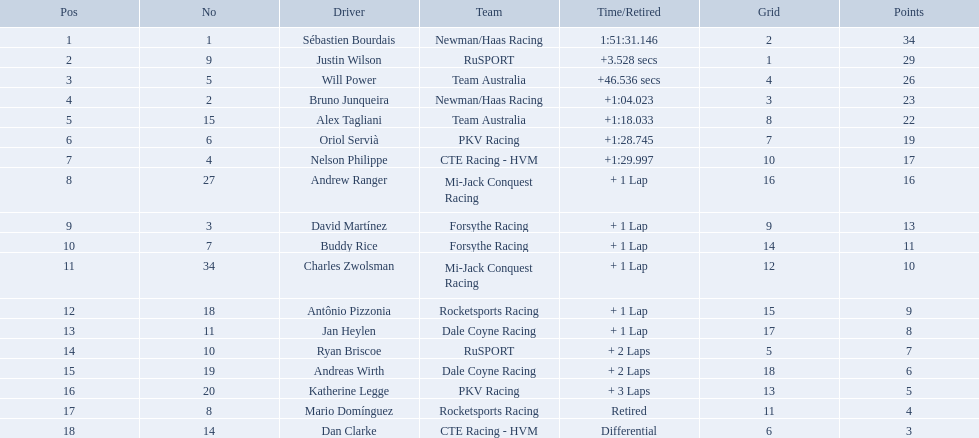How many points did first place receive? 34. How many did last place receive? 3. Who was the recipient of these last place points? Dan Clarke. Which teams participated in the 2006 gran premio telmex? Newman/Haas Racing, RuSPORT, Team Australia, Newman/Haas Racing, Team Australia, PKV Racing, CTE Racing - HVM, Mi-Jack Conquest Racing, Forsythe Racing, Forsythe Racing, Mi-Jack Conquest Racing, Rocketsports Racing, Dale Coyne Racing, RuSPORT, Dale Coyne Racing, PKV Racing, Rocketsports Racing, CTE Racing - HVM. Who were the drivers of these teams? Sébastien Bourdais, Justin Wilson, Will Power, Bruno Junqueira, Alex Tagliani, Oriol Servià, Nelson Philippe, Andrew Ranger, David Martínez, Buddy Rice, Charles Zwolsman, Antônio Pizzonia, Jan Heylen, Ryan Briscoe, Andreas Wirth, Katherine Legge, Mario Domínguez, Dan Clarke. Which driver finished last? Dan Clarke. What are the names of the drivers who were in position 14 through position 18? Ryan Briscoe, Andreas Wirth, Katherine Legge, Mario Domínguez, Dan Clarke. Of these , which ones didn't finish due to retired or differential? Mario Domínguez, Dan Clarke. Which one of the previous drivers retired? Mario Domínguez. Which of the drivers in question 2 had a differential? Dan Clarke. Parse the full table in json format. {'header': ['Pos', 'No', 'Driver', 'Team', 'Time/Retired', 'Grid', 'Points'], 'rows': [['1', '1', 'Sébastien Bourdais', 'Newman/Haas Racing', '1:51:31.146', '2', '34'], ['2', '9', 'Justin Wilson', 'RuSPORT', '+3.528 secs', '1', '29'], ['3', '5', 'Will Power', 'Team Australia', '+46.536 secs', '4', '26'], ['4', '2', 'Bruno Junqueira', 'Newman/Haas Racing', '+1:04.023', '3', '23'], ['5', '15', 'Alex Tagliani', 'Team Australia', '+1:18.033', '8', '22'], ['6', '6', 'Oriol Servià', 'PKV Racing', '+1:28.745', '7', '19'], ['7', '4', 'Nelson Philippe', 'CTE Racing - HVM', '+1:29.997', '10', '17'], ['8', '27', 'Andrew Ranger', 'Mi-Jack Conquest Racing', '+ 1 Lap', '16', '16'], ['9', '3', 'David Martínez', 'Forsythe Racing', '+ 1 Lap', '9', '13'], ['10', '7', 'Buddy Rice', 'Forsythe Racing', '+ 1 Lap', '14', '11'], ['11', '34', 'Charles Zwolsman', 'Mi-Jack Conquest Racing', '+ 1 Lap', '12', '10'], ['12', '18', 'Antônio Pizzonia', 'Rocketsports Racing', '+ 1 Lap', '15', '9'], ['13', '11', 'Jan Heylen', 'Dale Coyne Racing', '+ 1 Lap', '17', '8'], ['14', '10', 'Ryan Briscoe', 'RuSPORT', '+ 2 Laps', '5', '7'], ['15', '19', 'Andreas Wirth', 'Dale Coyne Racing', '+ 2 Laps', '18', '6'], ['16', '20', 'Katherine Legge', 'PKV Racing', '+ 3 Laps', '13', '5'], ['17', '8', 'Mario Domínguez', 'Rocketsports Racing', 'Retired', '11', '4'], ['18', '14', 'Dan Clarke', 'CTE Racing - HVM', 'Differential', '6', '3']]} Parse the full table in json format. {'header': ['Pos', 'No', 'Driver', 'Team', 'Time/Retired', 'Grid', 'Points'], 'rows': [['1', '1', 'Sébastien Bourdais', 'Newman/Haas Racing', '1:51:31.146', '2', '34'], ['2', '9', 'Justin Wilson', 'RuSPORT', '+3.528 secs', '1', '29'], ['3', '5', 'Will Power', 'Team Australia', '+46.536 secs', '4', '26'], ['4', '2', 'Bruno Junqueira', 'Newman/Haas Racing', '+1:04.023', '3', '23'], ['5', '15', 'Alex Tagliani', 'Team Australia', '+1:18.033', '8', '22'], ['6', '6', 'Oriol Servià', 'PKV Racing', '+1:28.745', '7', '19'], ['7', '4', 'Nelson Philippe', 'CTE Racing - HVM', '+1:29.997', '10', '17'], ['8', '27', 'Andrew Ranger', 'Mi-Jack Conquest Racing', '+ 1 Lap', '16', '16'], ['9', '3', 'David Martínez', 'Forsythe Racing', '+ 1 Lap', '9', '13'], ['10', '7', 'Buddy Rice', 'Forsythe Racing', '+ 1 Lap', '14', '11'], ['11', '34', 'Charles Zwolsman', 'Mi-Jack Conquest Racing', '+ 1 Lap', '12', '10'], ['12', '18', 'Antônio Pizzonia', 'Rocketsports Racing', '+ 1 Lap', '15', '9'], ['13', '11', 'Jan Heylen', 'Dale Coyne Racing', '+ 1 Lap', '17', '8'], ['14', '10', 'Ryan Briscoe', 'RuSPORT', '+ 2 Laps', '5', '7'], ['15', '19', 'Andreas Wirth', 'Dale Coyne Racing', '+ 2 Laps', '18', '6'], ['16', '20', 'Katherine Legge', 'PKV Racing', '+ 3 Laps', '13', '5'], ['17', '8', 'Mario Domínguez', 'Rocketsports Racing', 'Retired', '11', '4'], ['18', '14', 'Dan Clarke', 'CTE Racing - HVM', 'Differential', '6', '3']]} What drivers started in the top 10? Sébastien Bourdais, Justin Wilson, Will Power, Bruno Junqueira, Alex Tagliani, Oriol Servià, Nelson Philippe, Ryan Briscoe, Dan Clarke. Which of those drivers completed all 66 laps? Sébastien Bourdais, Justin Wilson, Will Power, Bruno Junqueira, Alex Tagliani, Oriol Servià, Nelson Philippe. Whom of these did not drive for team australia? Sébastien Bourdais, Justin Wilson, Bruno Junqueira, Oriol Servià, Nelson Philippe. Which of these drivers finished more then a minuet after the winner? Bruno Junqueira, Oriol Servià, Nelson Philippe. Which of these drivers had the highest car number? Oriol Servià. What was the highest amount of points scored in the 2006 gran premio? 34. Who scored 34 points? Sébastien Bourdais. Who are the drivers? Sébastien Bourdais, Justin Wilson, Will Power, Bruno Junqueira, Alex Tagliani, Oriol Servià, Nelson Philippe, Andrew Ranger, David Martínez, Buddy Rice, Charles Zwolsman, Antônio Pizzonia, Jan Heylen, Ryan Briscoe, Andreas Wirth, Katherine Legge, Mario Domínguez, Dan Clarke. What are their numbers? 1, 9, 5, 2, 15, 6, 4, 27, 3, 7, 34, 18, 11, 10, 19, 20, 8, 14. What are their positions? 1, 2, 3, 4, 5, 6, 7, 8, 9, 10, 11, 12, 13, 14, 15, 16, 17, 18. Which driver has the same number and position? Sébastien Bourdais. Who are all the drivers? Sébastien Bourdais, Justin Wilson, Will Power, Bruno Junqueira, Alex Tagliani, Oriol Servià, Nelson Philippe, Andrew Ranger, David Martínez, Buddy Rice, Charles Zwolsman, Antônio Pizzonia, Jan Heylen, Ryan Briscoe, Andreas Wirth, Katherine Legge, Mario Domínguez, Dan Clarke. What position did they reach? 1, 2, 3, 4, 5, 6, 7, 8, 9, 10, 11, 12, 13, 14, 15, 16, 17, 18. What is the number for each driver? 1, 9, 5, 2, 15, 6, 4, 27, 3, 7, 34, 18, 11, 10, 19, 20, 8, 14. And which player's number and position match? Sébastien Bourdais. 